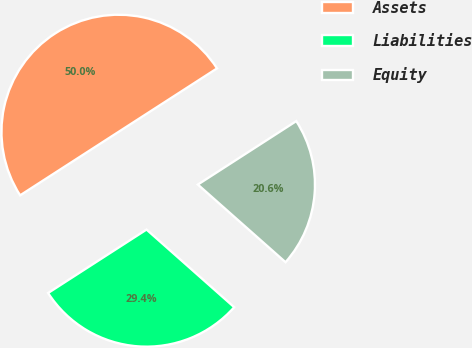<chart> <loc_0><loc_0><loc_500><loc_500><pie_chart><fcel>Assets<fcel>Liabilities<fcel>Equity<nl><fcel>50.0%<fcel>29.35%<fcel>20.65%<nl></chart> 